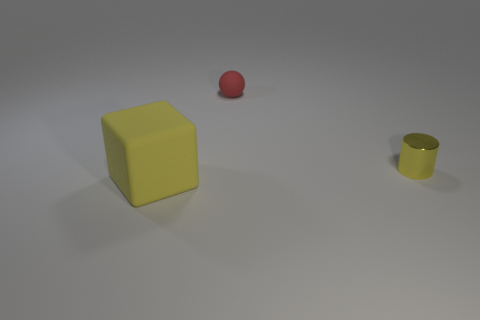Is the number of rubber balls greater than the number of things?
Ensure brevity in your answer.  No. What number of blocks are tiny metallic things or big matte things?
Your response must be concise. 1. The matte sphere has what color?
Offer a terse response. Red. Does the yellow object behind the large yellow block have the same size as the yellow object to the left of the tiny red matte sphere?
Give a very brief answer. No. Are there fewer small things than cylinders?
Your answer should be very brief. No. There is a small yellow cylinder; how many matte blocks are right of it?
Keep it short and to the point. 0. What is the material of the small red ball?
Provide a succinct answer. Rubber. Do the metallic thing and the matte block have the same color?
Your answer should be very brief. Yes. Is the number of big yellow objects that are on the left side of the large yellow matte object less than the number of small red objects?
Provide a succinct answer. Yes. What is the color of the rubber object to the left of the small red matte ball?
Give a very brief answer. Yellow. 